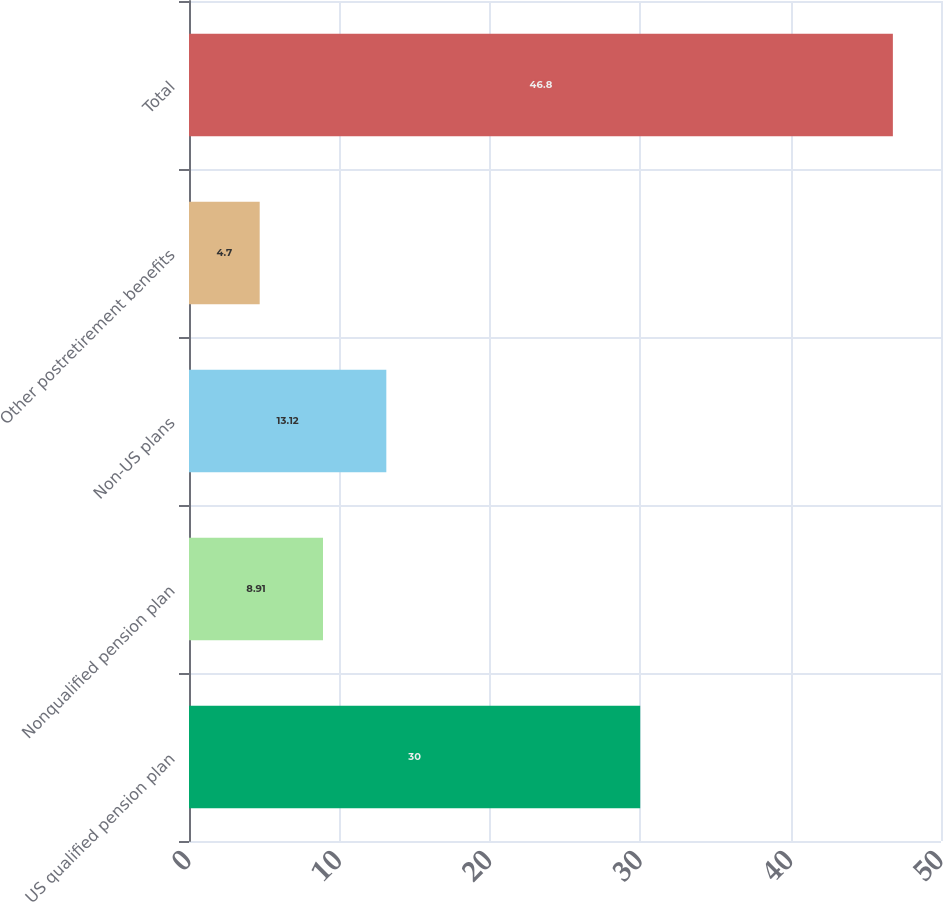Convert chart. <chart><loc_0><loc_0><loc_500><loc_500><bar_chart><fcel>US qualified pension plan<fcel>Nonqualified pension plan<fcel>Non-US plans<fcel>Other postretirement benefits<fcel>Total<nl><fcel>30<fcel>8.91<fcel>13.12<fcel>4.7<fcel>46.8<nl></chart> 